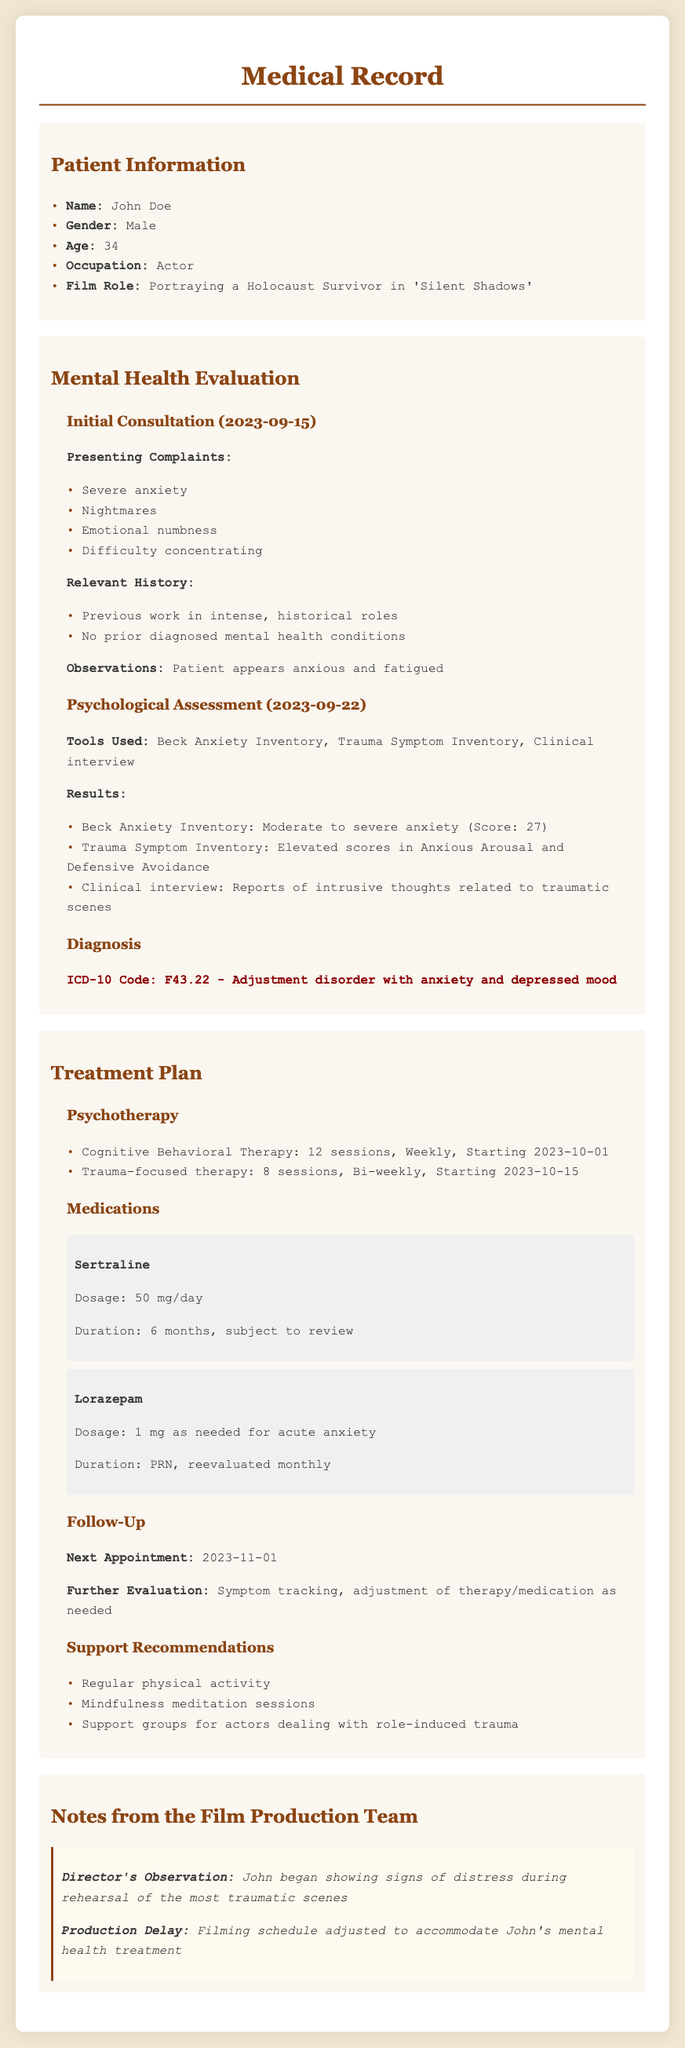what is the patient's name? The patient's name is listed in the Patient Information section of the document.
Answer: John Doe what is the patient's age? The patient's age is stated in the Patient Information section of the document.
Answer: 34 what film role is the patient portraying? The film role is mentioned in the Patient Information section.
Answer: Portraying a Holocaust Survivor in 'Silent Shadows' when was the initial consultation? The date of the initial consultation is detailed in the Mental Health Evaluation section.
Answer: 2023-09-15 what medication is prescribed for acute anxiety? The specific medication for acute anxiety is found in the Treatment Plan section.
Answer: Lorazepam what is the ICD-10 code for the diagnosis? The ICD-10 code is provided in the Diagnosis subsection of the document.
Answer: F43.22 how many sessions of Cognitive Behavioral Therapy are scheduled? The number of sessions is specified in the Treatment Plan section under Psychotherapy.
Answer: 12 sessions what did the director observe about the patient? The director's observation is noted in the Notes from the Film Production Team section.
Answer: Signs of distress during rehearsal what type of therapy starts on 2023-10-15? The therapy type starting on this date is listed in the Treatment Plan section.
Answer: Trauma-focused therapy what is the dosage for Sertraline? The dosage is described in the Medications subsection of the document.
Answer: 50 mg/day 